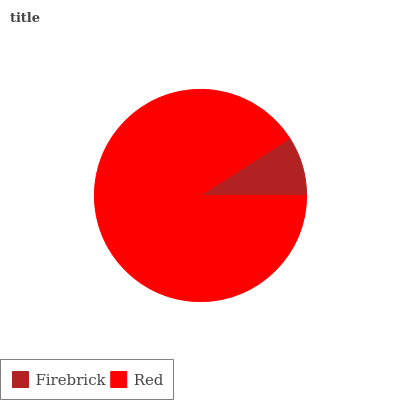Is Firebrick the minimum?
Answer yes or no. Yes. Is Red the maximum?
Answer yes or no. Yes. Is Red the minimum?
Answer yes or no. No. Is Red greater than Firebrick?
Answer yes or no. Yes. Is Firebrick less than Red?
Answer yes or no. Yes. Is Firebrick greater than Red?
Answer yes or no. No. Is Red less than Firebrick?
Answer yes or no. No. Is Red the high median?
Answer yes or no. Yes. Is Firebrick the low median?
Answer yes or no. Yes. Is Firebrick the high median?
Answer yes or no. No. Is Red the low median?
Answer yes or no. No. 